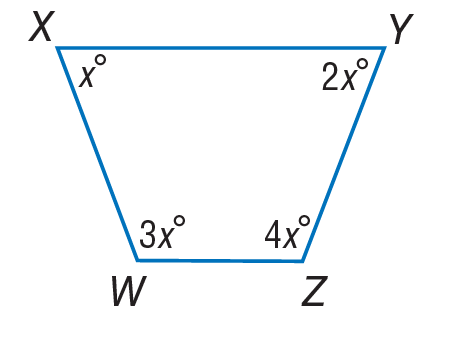Answer the mathemtical geometry problem and directly provide the correct option letter.
Question: Find m \angle Z.
Choices: A: 18 B: 36 C: 72 D: 144 D 